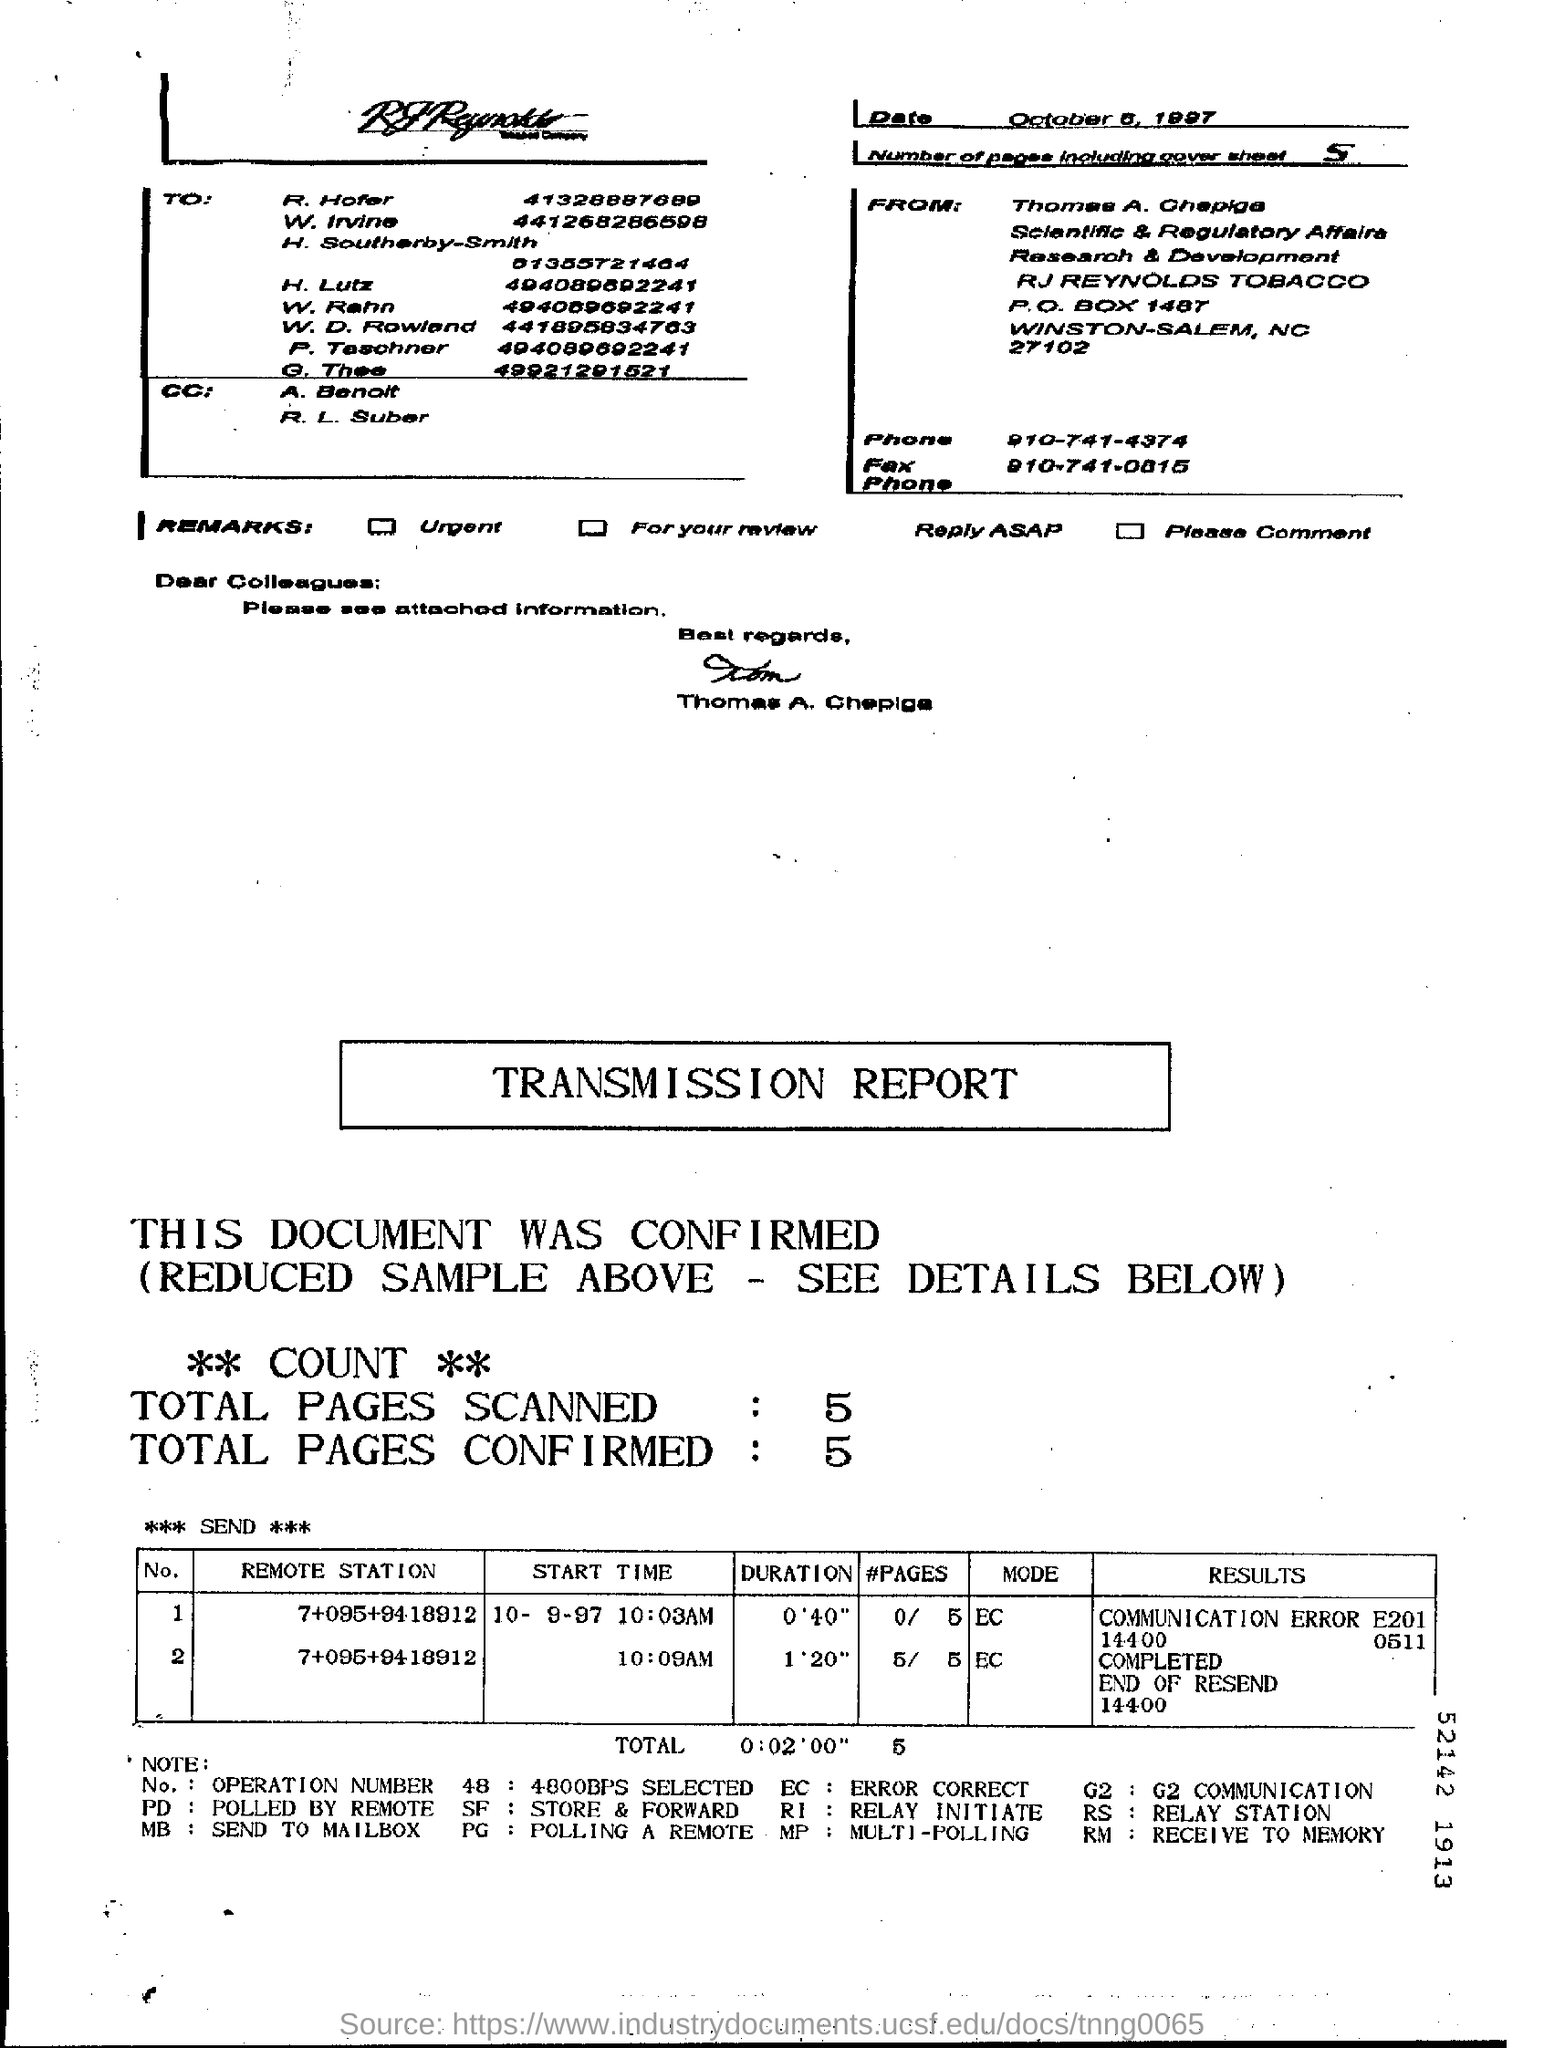Who has signed the fax document?
Offer a terse response. Thomas A. Chepiga. How many pages are there in the fax including cover sheet?
Your answer should be very brief. 5. What is the total pages scanned given in the transmission report?
Make the answer very short. 5. What is the Total duration mentioned in the transmission report?
Offer a terse response. 0:02'00". 